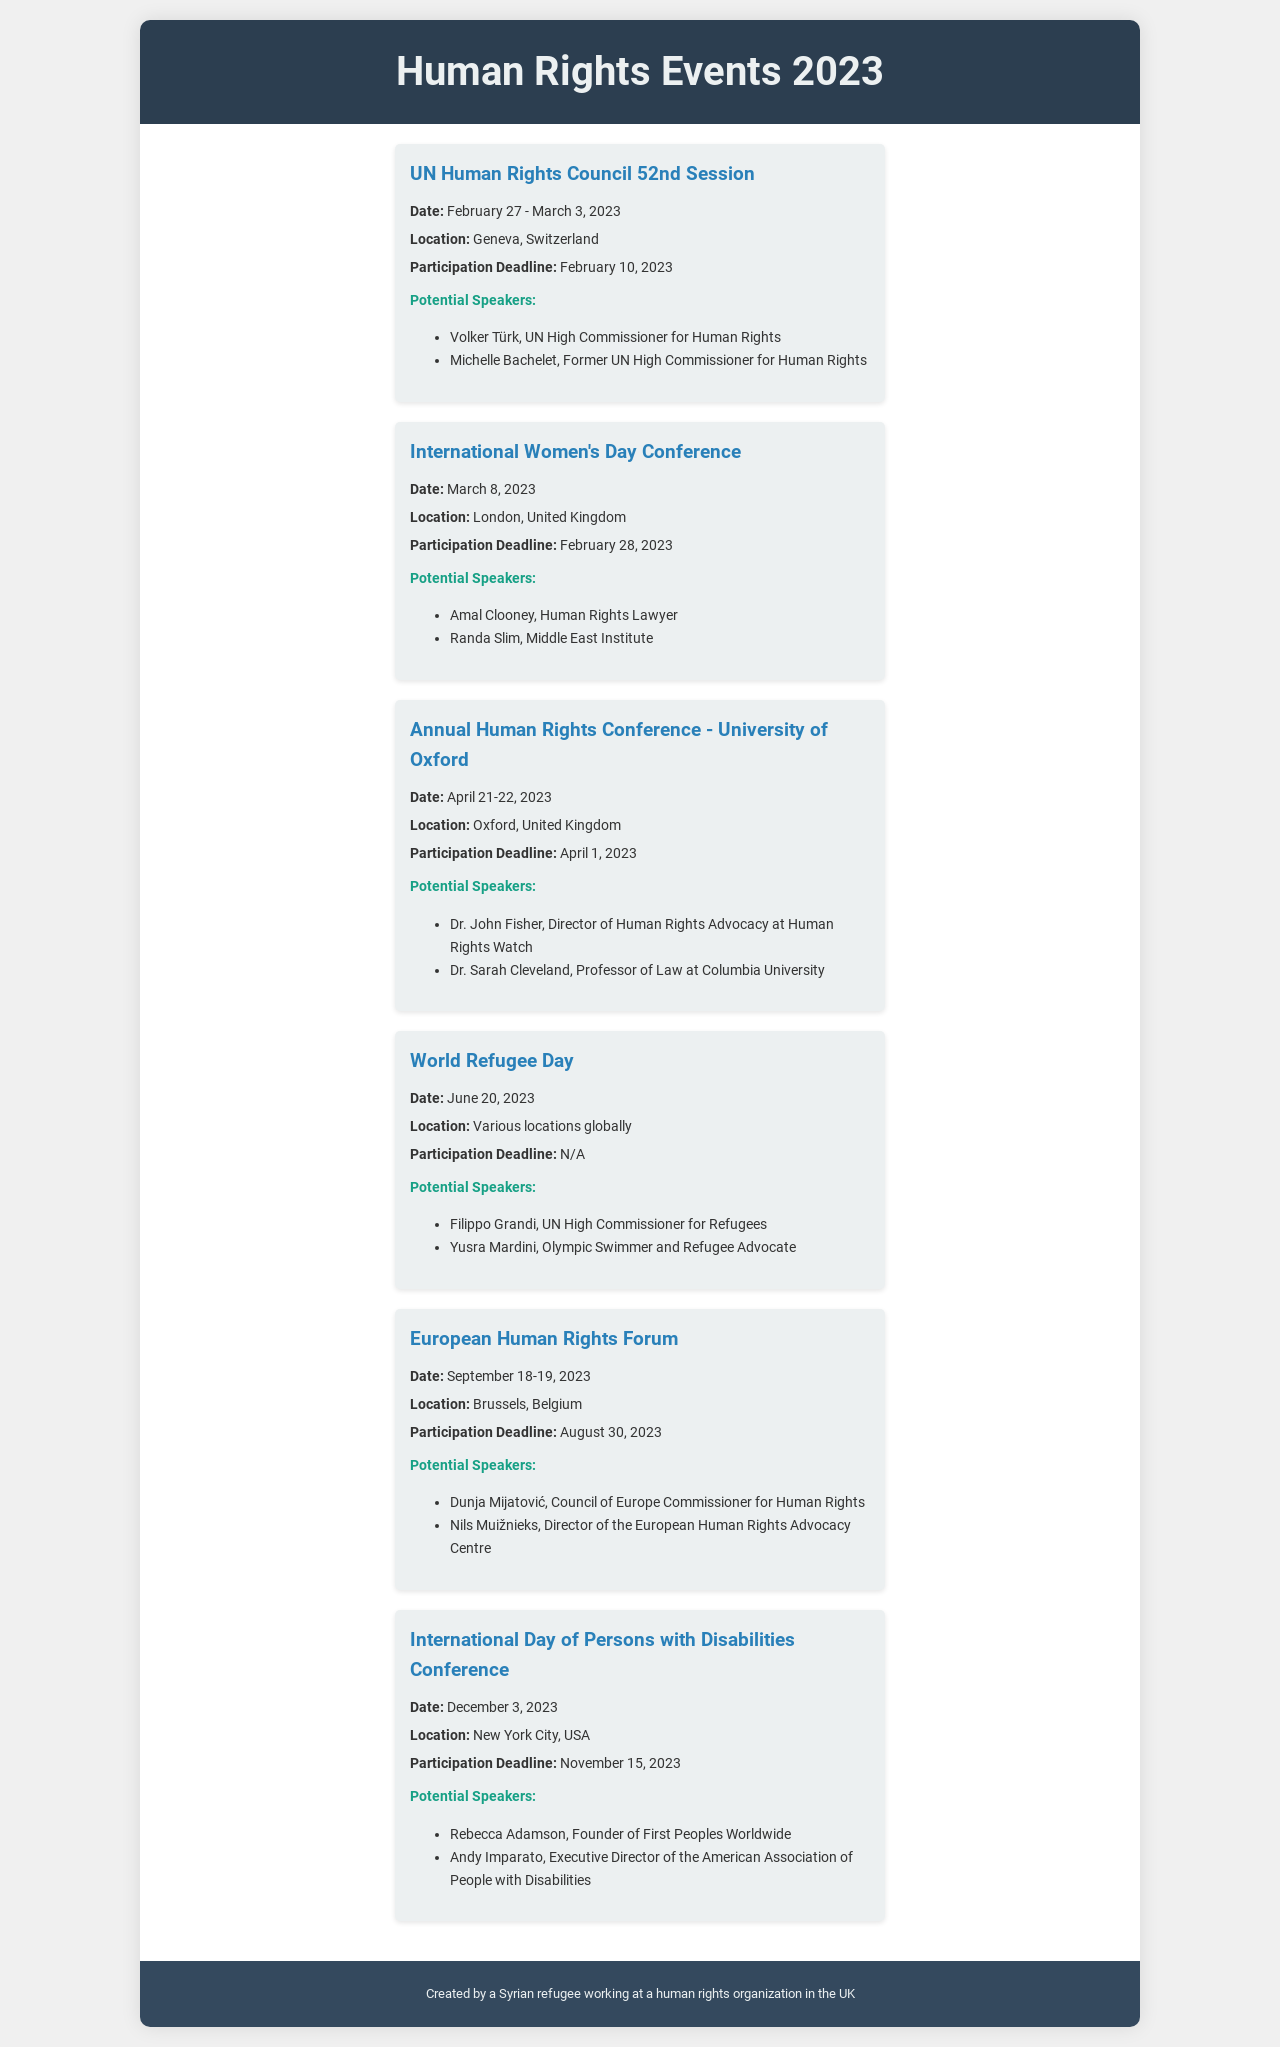what is the date of the UN Human Rights Council 52nd Session? The date of this event is specifically mentioned in the document as February 27 - March 3, 2023.
Answer: February 27 - March 3, 2023 who will be a potential speaker at the International Women's Day Conference? The document lists potential speakers for the International Women's Day Conference, including Amal Clooney, a Human Rights Lawyer.
Answer: Amal Clooney when does the deadline for participation in the European Human Rights Forum end? The document clearly states that the participation deadline for the European Human Rights Forum is August 30, 2023.
Answer: August 30, 2023 how many days is the Annual Human Rights Conference at the University of Oxford? The event spans two days, as specified in the document which mentions April 21-22, 2023.
Answer: 2 days where is the International Day of Persons with Disabilities Conference held? The document states that the location for this conference is New York City, USA.
Answer: New York City, USA what is one major theme of the World Refugee Day? This event is focused on the theme of recognizing and advocating for refugees globally, although the document does not state specifics.
Answer: Refugees who is the UN High Commissioner for Refugees mentioned as a speaker for World Refugee Day? The document provides a list of potential speakers, including Filippo Grandi as the UN High Commissioner for Refugees.
Answer: Filippo Grandi has the participation deadline for World Refugee Day been set? The document mentions that there is no participation deadline for the World Refugee Day event.
Answer: N/A 